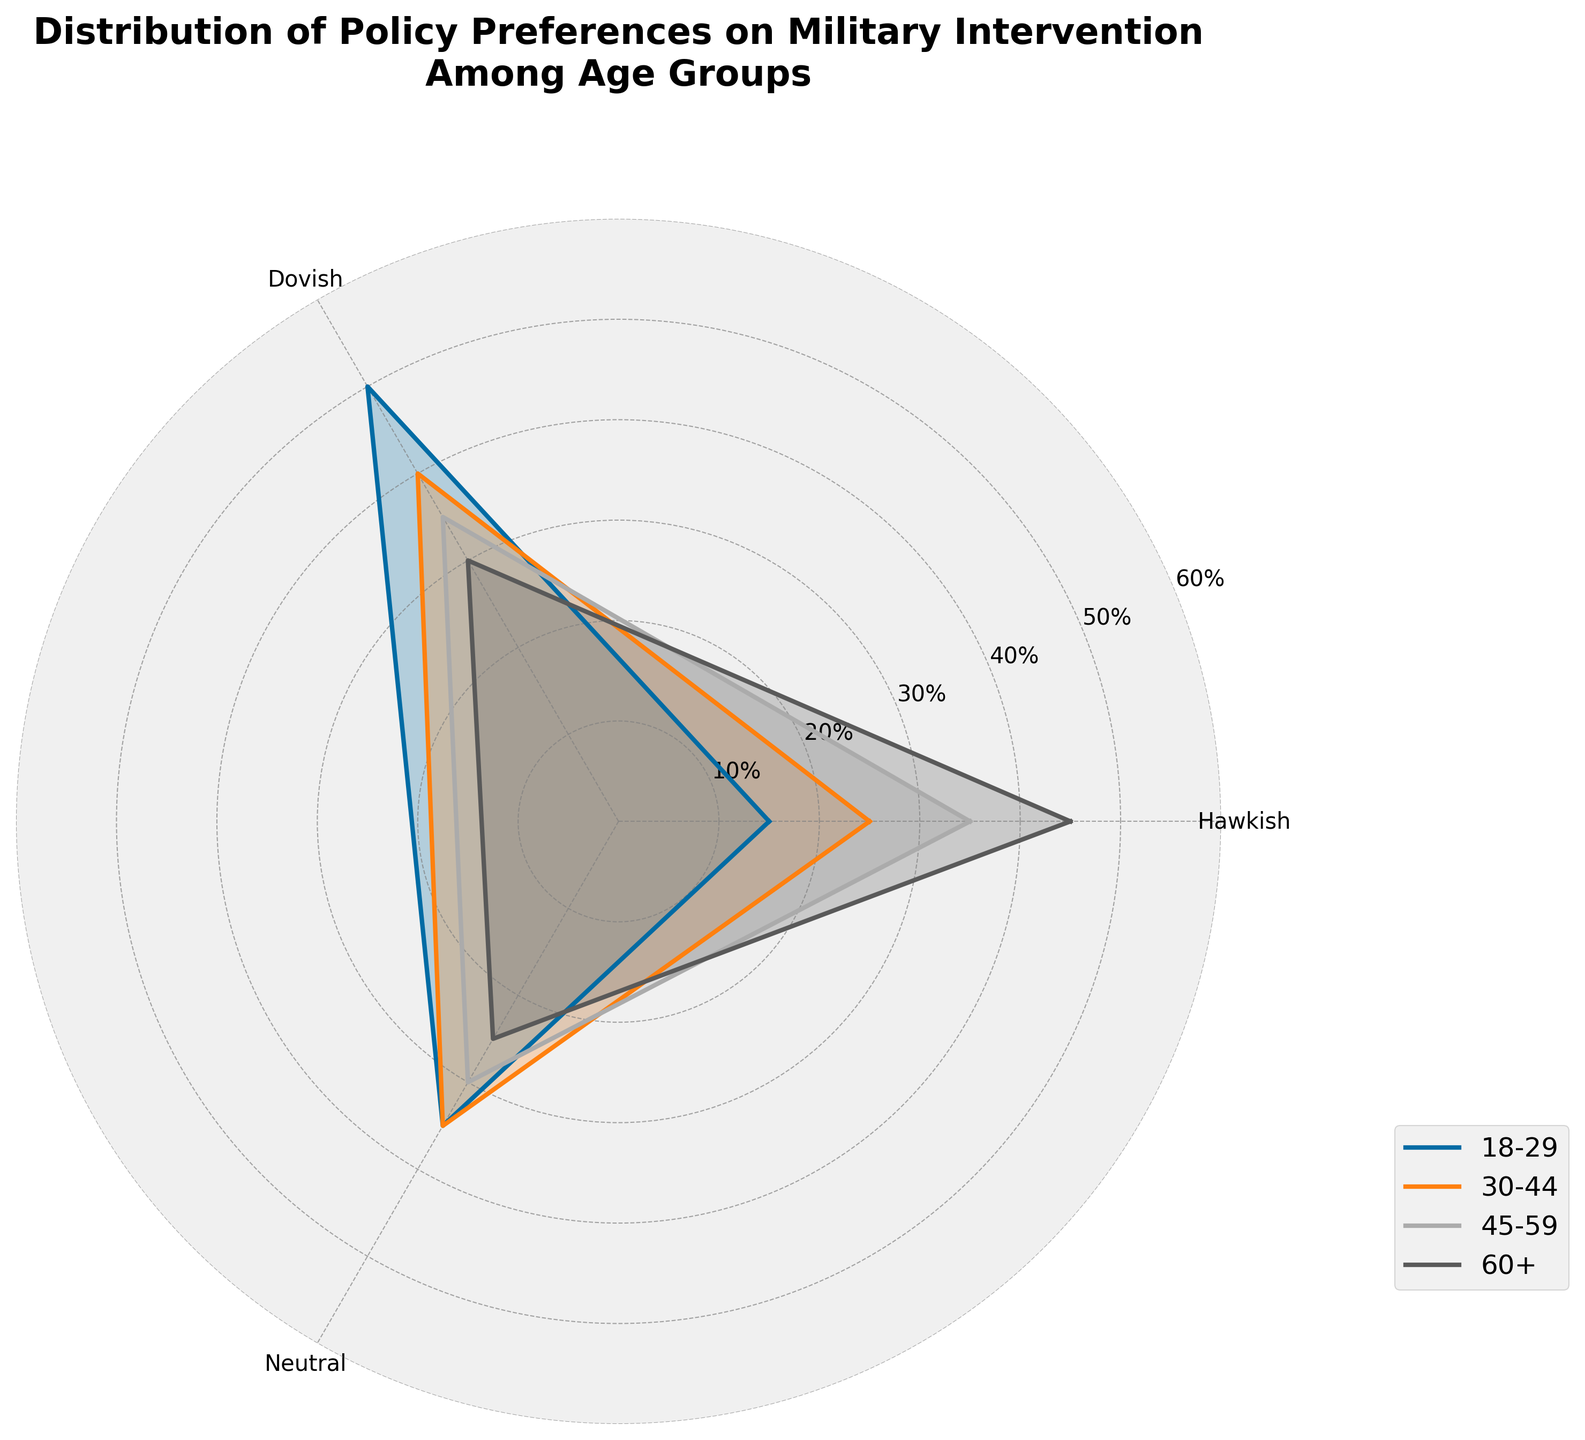What is the title of the chart? The title is located at the top of the chart and typically explains what the chart is about.
Answer: Distribution of Policy Preferences on Military Intervention Among Age Groups Which age group has the highest percentage of hawkish policy preferences? By examining the values for the 'Hawkish' category in each age group's plot lines and finding the highest point, we can determine the age group.
Answer: 60+ How do the hawkish and dovish preferences compare for the 30-44 age group? For the 30-44 age group, find the values corresponding to 'Hawkish' and 'Dovish' categories and compare their heights.
Answer: Hawkish: 25%, Dovish: 40% Which age group has the lowest percentage of neutral policy preferences? Identify the age group with the smallest value in the 'Neutral' category by looking at the lowest point on the radial axis for neutral preference.
Answer: 60+ What is the difference between the hawkish preferences of the youngest and oldest age groups? Subtract the hawkish percentage of the 18-29 age group from that of the 60+ age group.
Answer: 30% What is the average dovish preference percentage across all age groups? Add and average the dovish preferences: (50 + 40 + 35 + 30) / 4
Answer: 38.75% Is there any age group where the percentage of hawkish and neutral preferences are equal? Check each age group's plot and compare the hawkish and neutral percentages to see if they are the same.
Answer: No How do the policy preferences vary with age? Compare the trend seen in each age group: Younger groups tend to be more dovish while older groups are more hawkish.
Answer: Younger more dovish, older more hawkish Which age group shows the most balanced distribution of preferences? Identify the age group where the values for hawkish, dovish, and neutral preferences are closest together.
Answer: 45-59 Among all the age groups, which preference category shows the most variation? Observe the widest spread among the category values across the age groups; hawkish preferences exhibit increasing values as age increases.
Answer: Hawkish 